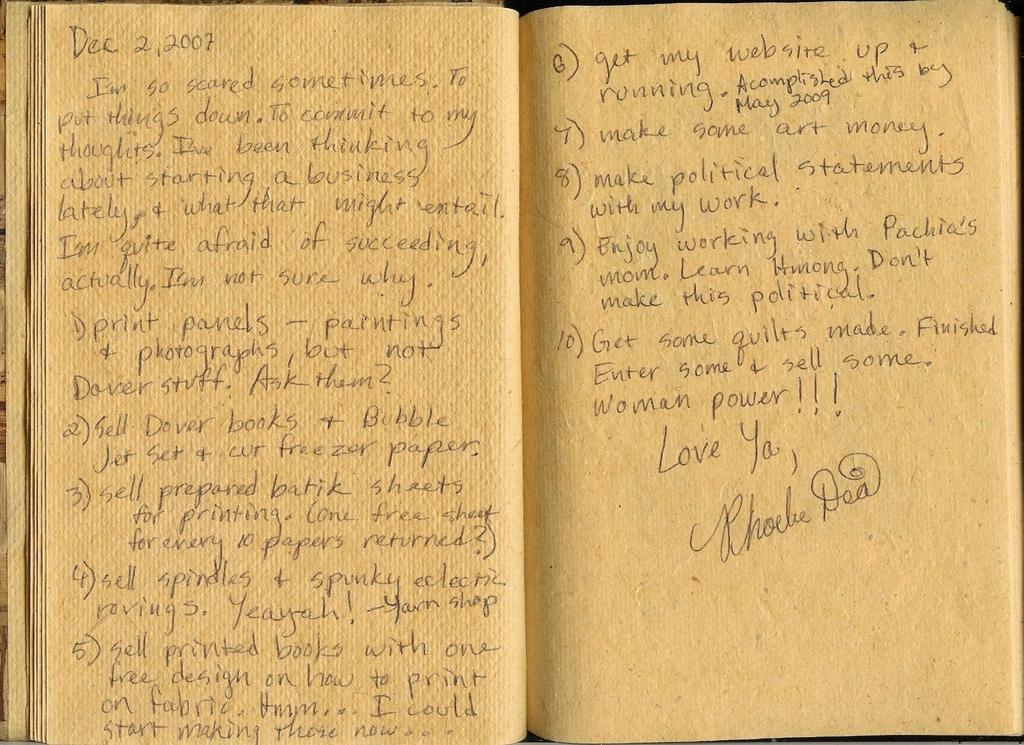Provide a one-sentence caption for the provided image. Phoebe Dea wrote 10 goals on the yellow pages of a book. 